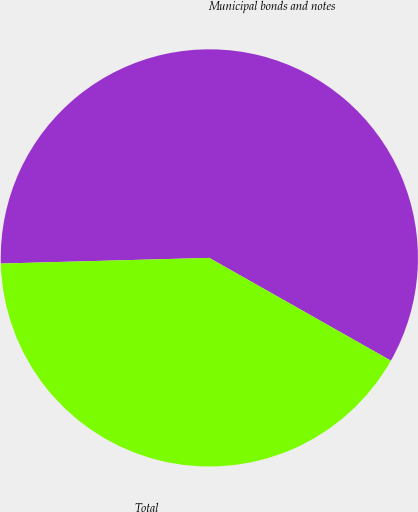Convert chart. <chart><loc_0><loc_0><loc_500><loc_500><pie_chart><fcel>Municipal bonds and notes<fcel>Total<nl><fcel>58.63%<fcel>41.37%<nl></chart> 